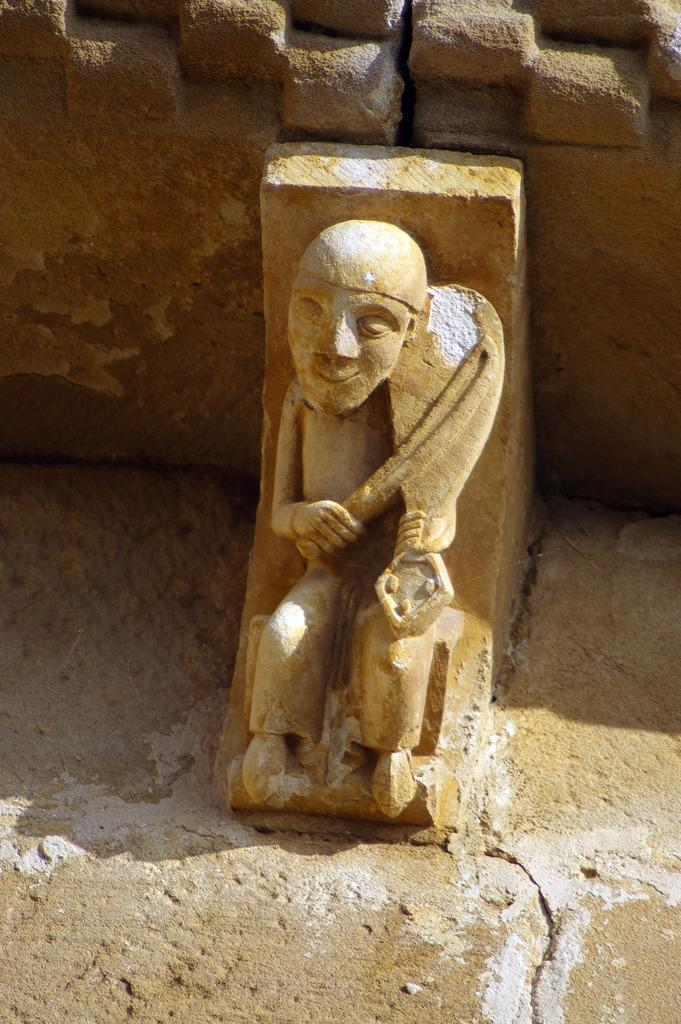What is the main subject of the image? The main subject of the image is a stone carving of a person. What color is the stone carving? The stone carving is in brown color. What can be seen in the background of the image? There is a big rock in the background of the image. Can you tell me how many goldfish are swimming around the stone carving in the image? There are no goldfish present in the image; it features a stone carving of a person and a big rock in the background. 